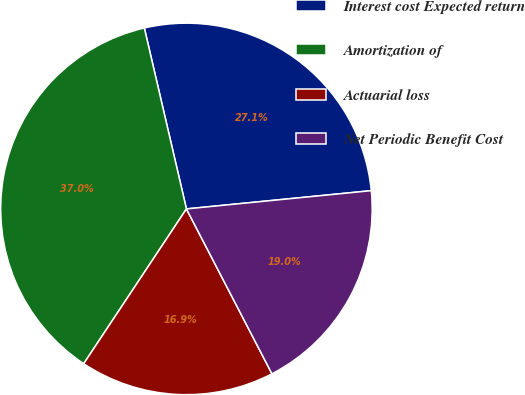<chart> <loc_0><loc_0><loc_500><loc_500><pie_chart><fcel>Interest cost Expected return<fcel>Amortization of<fcel>Actuarial loss<fcel>Net Periodic Benefit Cost<nl><fcel>27.07%<fcel>37.03%<fcel>16.94%<fcel>18.95%<nl></chart> 